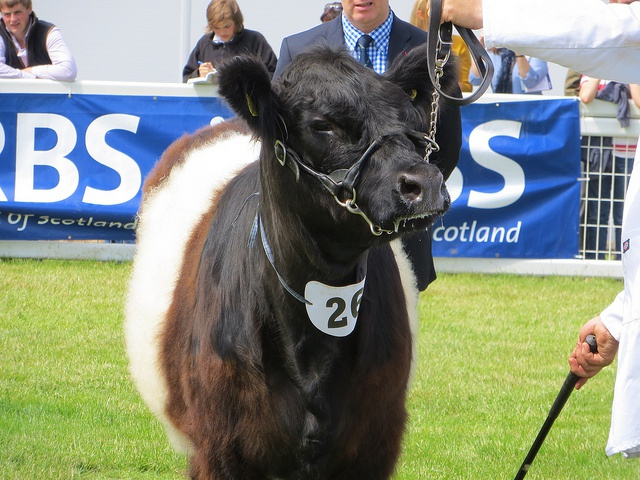Describe the objects in this image and their specific colors. I can see cow in tan, black, gray, and white tones, people in tan, white, and darkgray tones, people in tan, black, and gray tones, people in tan, lavender, black, brown, and gray tones, and people in tan, gray, and black tones in this image. 